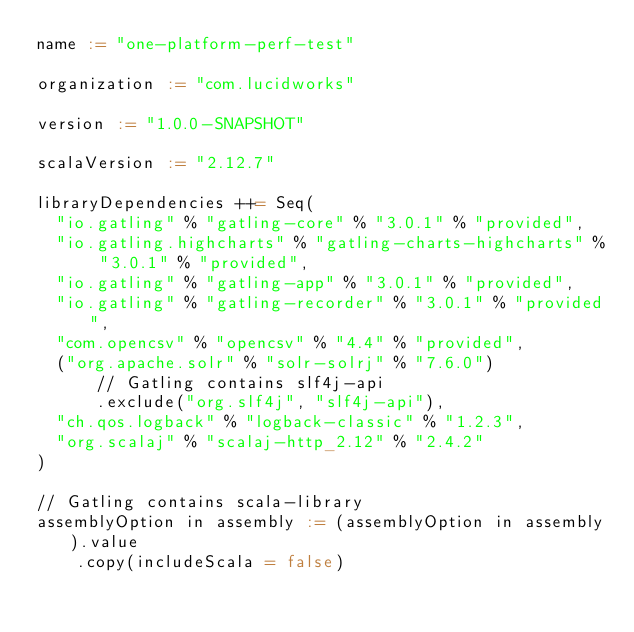<code> <loc_0><loc_0><loc_500><loc_500><_Scala_>name := "one-platform-perf-test"

organization := "com.lucidworks"

version := "1.0.0-SNAPSHOT"

scalaVersion := "2.12.7"

libraryDependencies ++= Seq(
  "io.gatling" % "gatling-core" % "3.0.1" % "provided",
  "io.gatling.highcharts" % "gatling-charts-highcharts" % "3.0.1" % "provided",
  "io.gatling" % "gatling-app" % "3.0.1" % "provided",
  "io.gatling" % "gatling-recorder" % "3.0.1" % "provided",
  "com.opencsv" % "opencsv" % "4.4" % "provided",
  ("org.apache.solr" % "solr-solrj" % "7.6.0")
      // Gatling contains slf4j-api
      .exclude("org.slf4j", "slf4j-api"),
  "ch.qos.logback" % "logback-classic" % "1.2.3",
  "org.scalaj" % "scalaj-http_2.12" % "2.4.2"
)

// Gatling contains scala-library
assemblyOption in assembly := (assemblyOption in assembly).value
    .copy(includeScala = false)</code> 